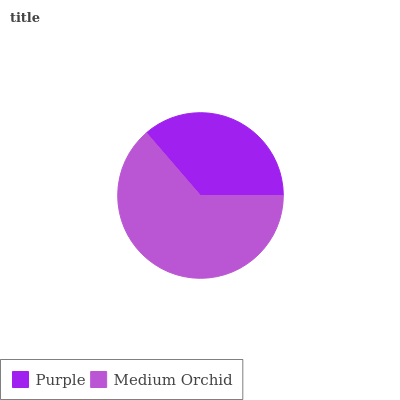Is Purple the minimum?
Answer yes or no. Yes. Is Medium Orchid the maximum?
Answer yes or no. Yes. Is Medium Orchid the minimum?
Answer yes or no. No. Is Medium Orchid greater than Purple?
Answer yes or no. Yes. Is Purple less than Medium Orchid?
Answer yes or no. Yes. Is Purple greater than Medium Orchid?
Answer yes or no. No. Is Medium Orchid less than Purple?
Answer yes or no. No. Is Medium Orchid the high median?
Answer yes or no. Yes. Is Purple the low median?
Answer yes or no. Yes. Is Purple the high median?
Answer yes or no. No. Is Medium Orchid the low median?
Answer yes or no. No. 